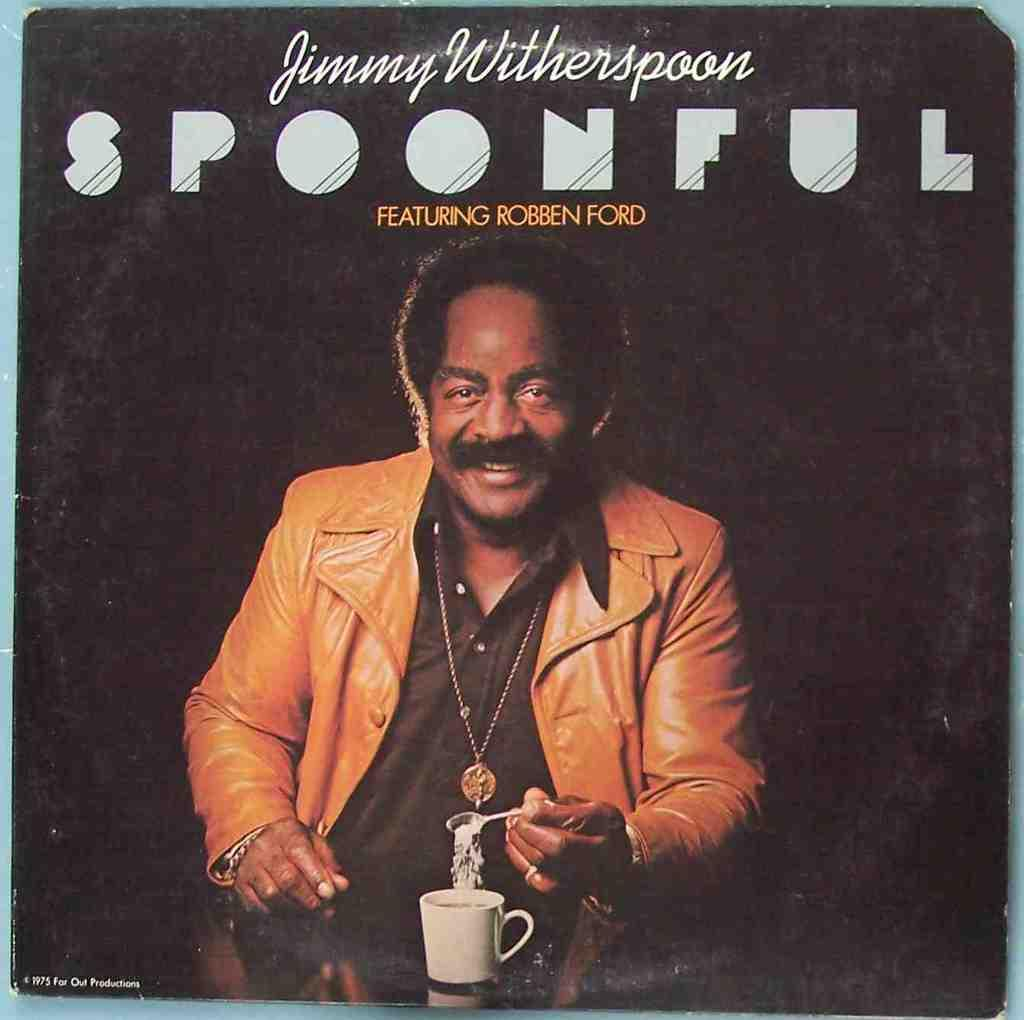What is present on the poster in the image? There is a poster in the image, and it contains text and an image of a person holding a spoon. Can you describe the image on the poster? The image on the poster features a person holding a spoon. What else can be seen in the image besides the poster? There is a cup visible in the image. How many pigs are present in the image? There are no pigs present in the image; it features a poster with text and an image of a person holding a spoon, along with a visible cup. 